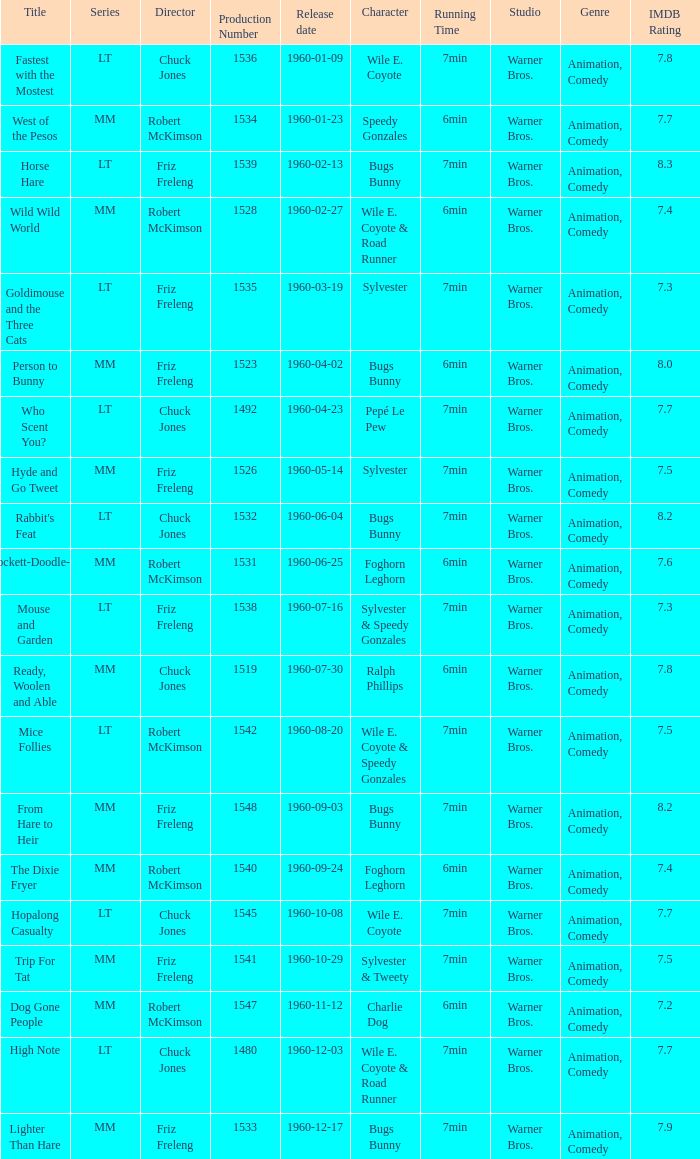What is the Series number of the episode with a production number of 1547? MM. 